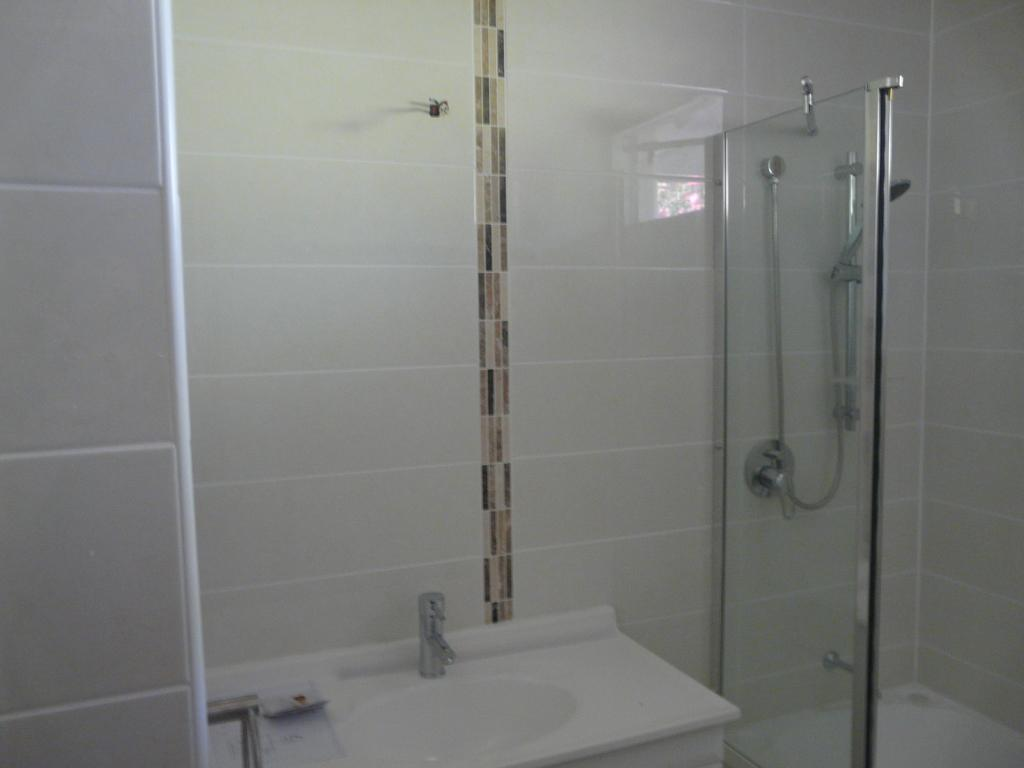What is the main fixture in the image? There is a washbasin in the image. What can be used to control the flow of water in the image? There is a tap in the image. What is another fixture for bathing in the image? There is a bathtub in the image. What is the third fixture for bathing in the image? There is a shower in the image. What colors are used for the wall in the image? The wall is in white and cream. How much income does the boat depicted on the paper in the image generate? There is no boat or paper present in the image, so it is not possible to determine the income generated. 